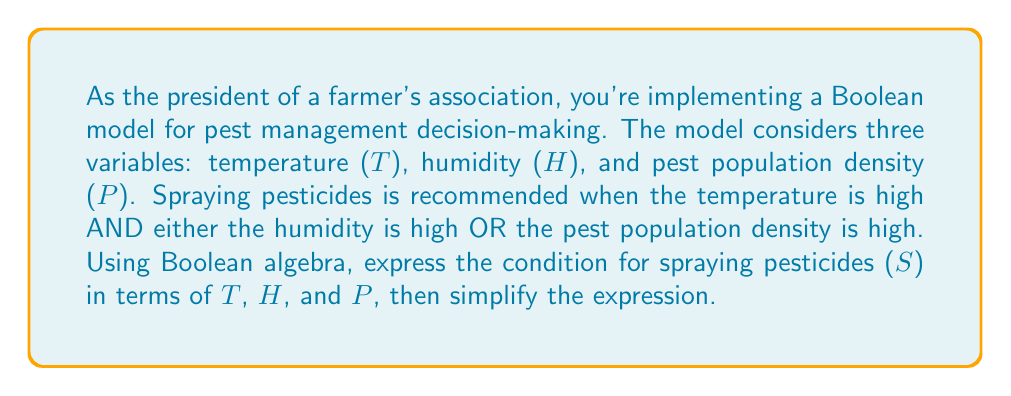Teach me how to tackle this problem. Let's approach this step-by-step:

1) First, let's define our variables:
   T: Temperature is high
   H: Humidity is high
   P: Pest population density is high
   S: Spray pesticides

2) From the given conditions, we can express S as:
   $S = T \cdot (H + P)$

3) This expression is already in its simplest form, as it uses the distributive property of Boolean algebra. However, let's verify this:

4) We could try to expand this:
   $S = T \cdot H + T \cdot P$

5) But this expanded form is not simpler than our original expression. In Boolean algebra, the form $A \cdot (B + C)$ is often preferred over $A \cdot B + A \cdot C$ as it's more compact.

6) We can also verify that this expression correctly represents our conditions:
   - If T is false (0), S will always be false (0), regardless of H and P.
   - If T is true (1) and either H or P is true (1), S will be true (1).
   - If T is true (1) but both H and P are false (0), S will be false (0).

Therefore, the simplified Boolean expression for the spraying condition is $T \cdot (H + P)$.
Answer: $S = T \cdot (H + P)$ 